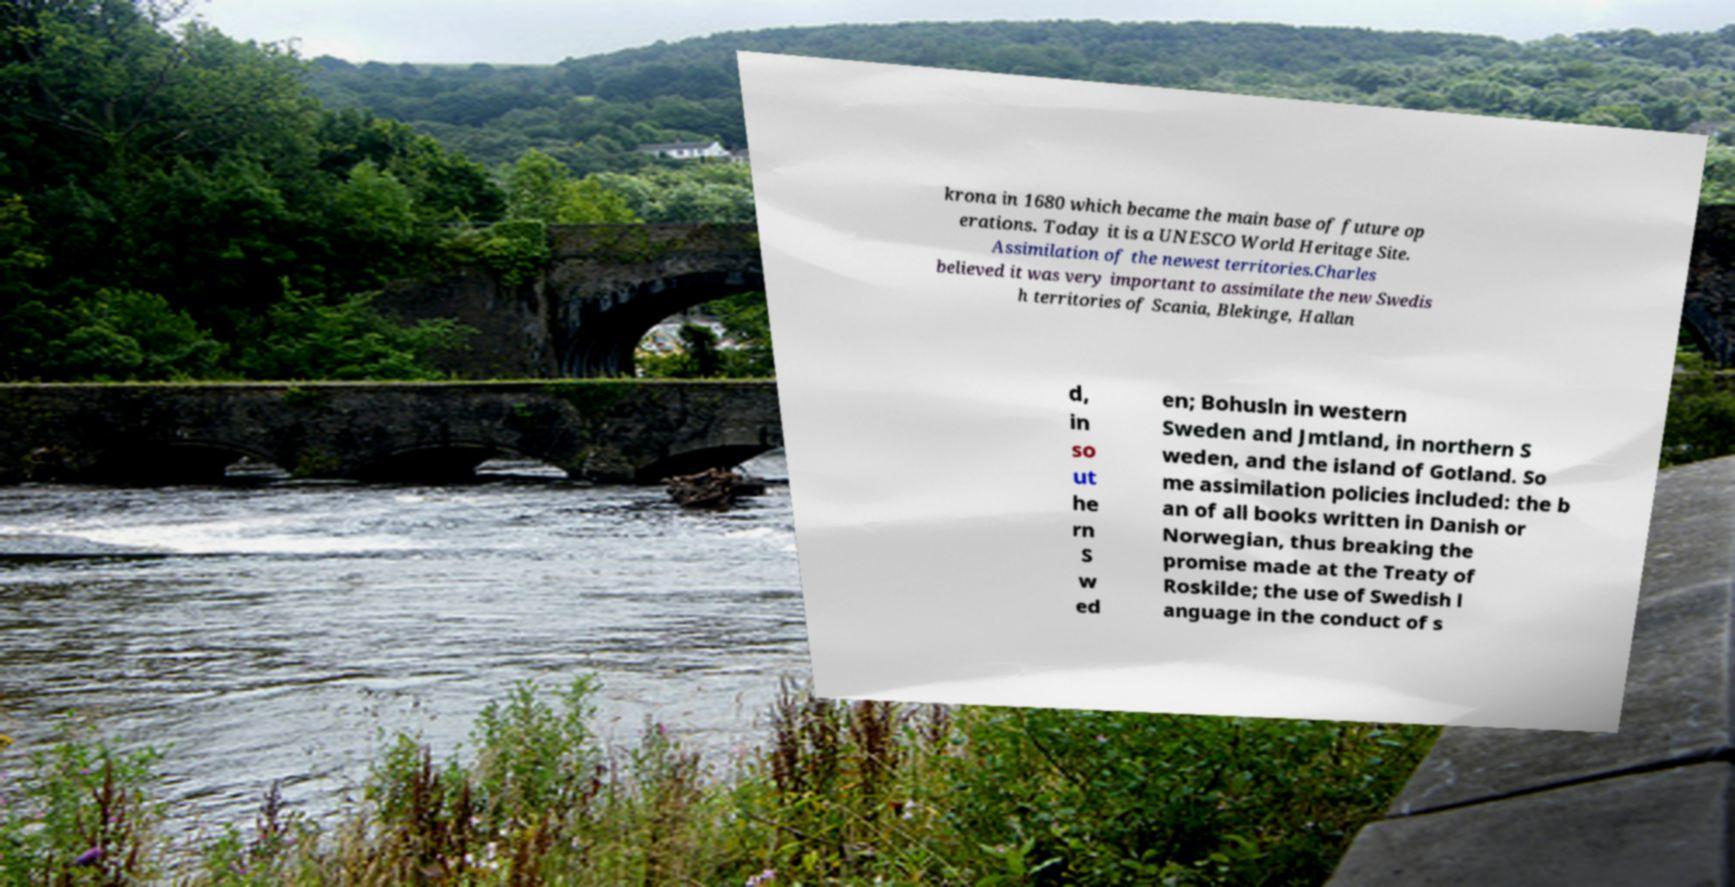Can you read and provide the text displayed in the image?This photo seems to have some interesting text. Can you extract and type it out for me? krona in 1680 which became the main base of future op erations. Today it is a UNESCO World Heritage Site. Assimilation of the newest territories.Charles believed it was very important to assimilate the new Swedis h territories of Scania, Blekinge, Hallan d, in so ut he rn S w ed en; Bohusln in western Sweden and Jmtland, in northern S weden, and the island of Gotland. So me assimilation policies included: the b an of all books written in Danish or Norwegian, thus breaking the promise made at the Treaty of Roskilde; the use of Swedish l anguage in the conduct of s 